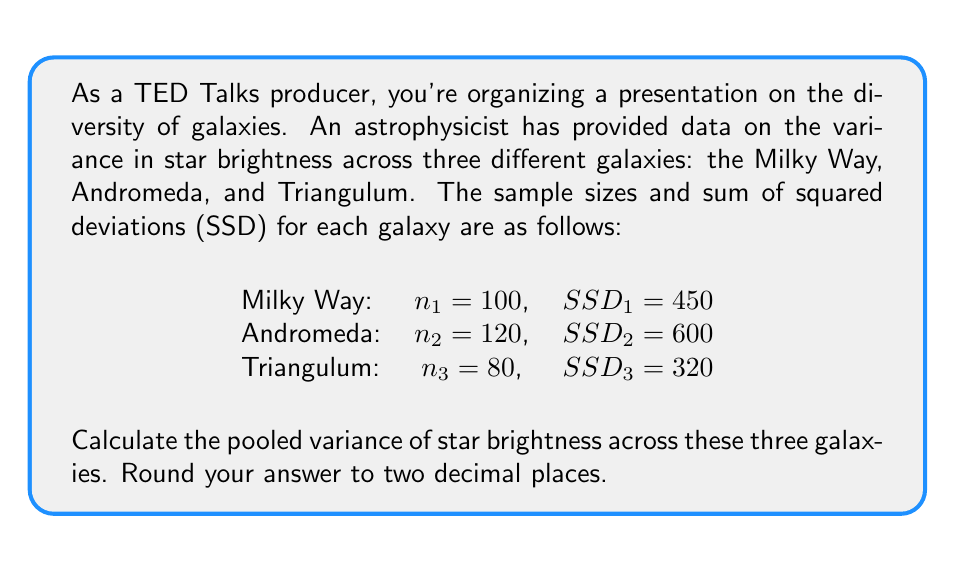Show me your answer to this math problem. To calculate the pooled variance, we'll follow these steps:

1) The pooled variance formula is:

   $$ s_p^2 = \frac{SSD_1 + SSD_2 + SSD_3}{(n_1 - 1) + (n_2 - 1) + (n_3 - 1)} $$

   Where $s_p^2$ is the pooled variance, $SSD_i$ is the sum of squared deviations for each group, and $n_i$ is the sample size for each group.

2) Let's substitute the given values:

   $$ s_p^2 = \frac{450 + 600 + 320}{(100 - 1) + (120 - 1) + (80 - 1)} $$

3) Simplify the numerator and denominator:

   $$ s_p^2 = \frac{1370}{99 + 119 + 79} = \frac{1370}{297} $$

4) Perform the division:

   $$ s_p^2 = 4.6127946127946127... $$

5) Rounding to two decimal places:

   $$ s_p^2 \approx 4.61 $$

This pooled variance represents the average variability in star brightness across the three galaxies, taking into account their different sample sizes.
Answer: 4.61 